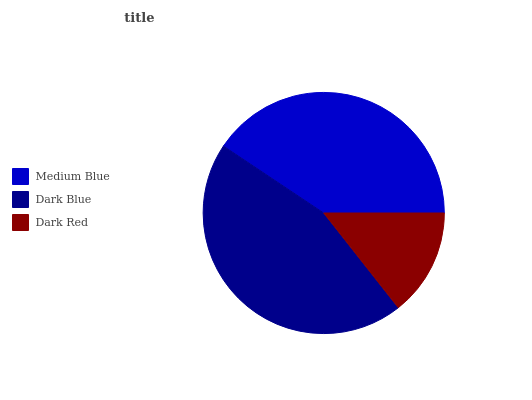Is Dark Red the minimum?
Answer yes or no. Yes. Is Dark Blue the maximum?
Answer yes or no. Yes. Is Dark Blue the minimum?
Answer yes or no. No. Is Dark Red the maximum?
Answer yes or no. No. Is Dark Blue greater than Dark Red?
Answer yes or no. Yes. Is Dark Red less than Dark Blue?
Answer yes or no. Yes. Is Dark Red greater than Dark Blue?
Answer yes or no. No. Is Dark Blue less than Dark Red?
Answer yes or no. No. Is Medium Blue the high median?
Answer yes or no. Yes. Is Medium Blue the low median?
Answer yes or no. Yes. Is Dark Red the high median?
Answer yes or no. No. Is Dark Red the low median?
Answer yes or no. No. 